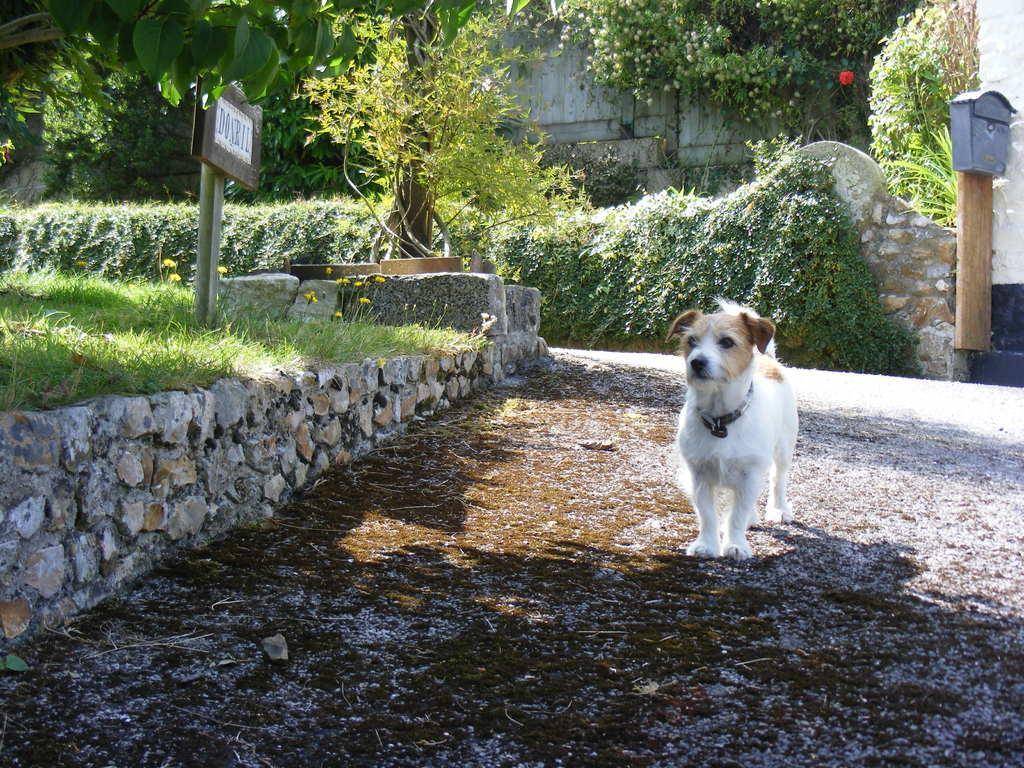Please provide a concise description of this image. In this picture we can see a dog is standing in the front, on the left side there is a board and grass, we can see some plants in the background, on the right side there is a mailbox. 